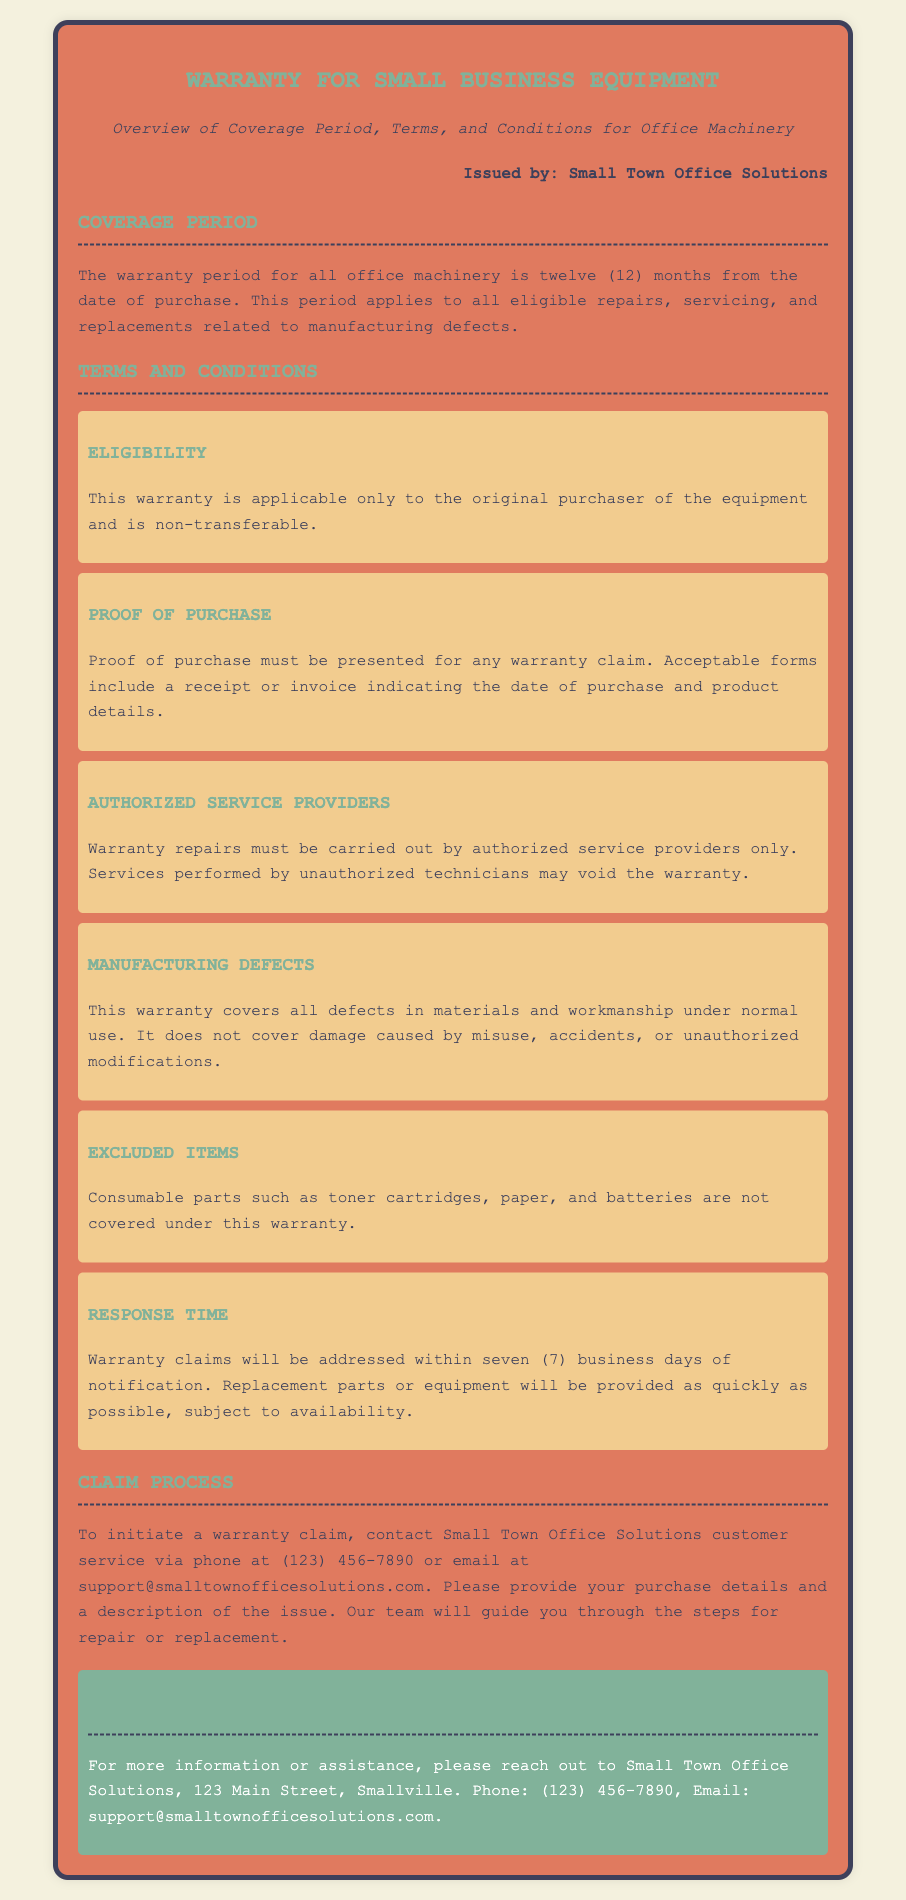What is the warranty period? The warranty period is defined as twelve months from the date of purchase for all office machinery.
Answer: twelve months Who is eligible for the warranty? Eligibility is focused on the original purchaser, making the warranty non-transferable.
Answer: original purchaser What must be presented for a warranty claim? For a warranty claim, proof of purchase must be shown to validate the claim.
Answer: proof of purchase What is excluded from warranty coverage? The warranty does not cover consumable parts such as toner cartridges, paper, and batteries.
Answer: consumable parts How long does it take to address warranty claims? The response time for warranty claims is mentioned as seven business days after notification.
Answer: seven business days What are warranty repairs required to be carried out by? Warranty repairs must be conducted by authorized service providers as stipulated in the terms.
Answer: authorized service providers What is the contact phone number for warranty claims? The contact number provided for warranty claims assistance is important for customers to initiate the process.
Answer: (123) 456-7890 What is the name of the issuing entity? The document specifies the entity that issues the warranty to be Small Town Office Solutions.
Answer: Small Town Office Solutions 